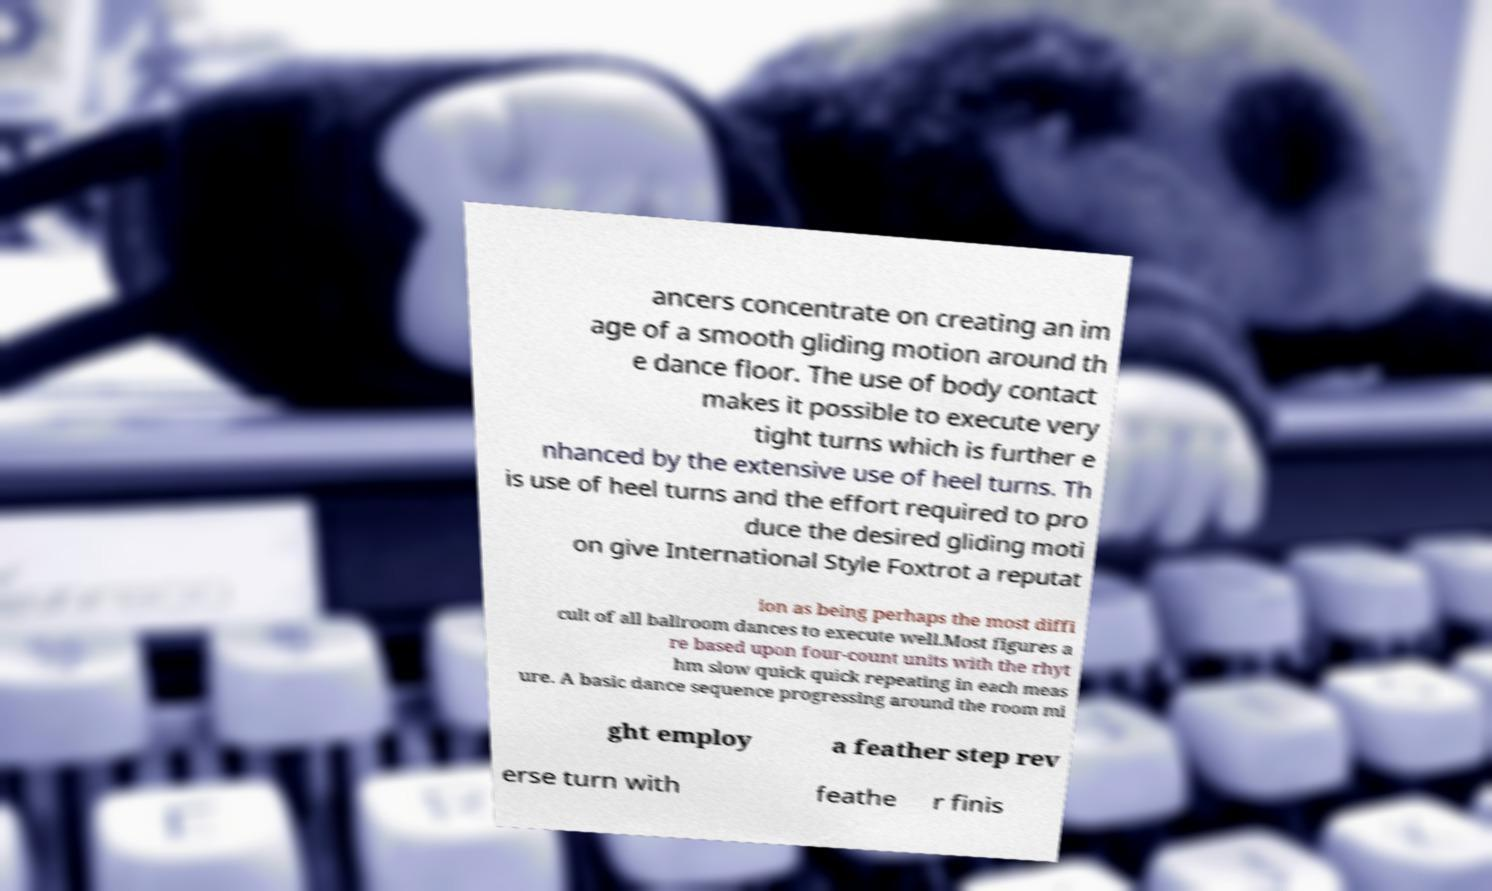There's text embedded in this image that I need extracted. Can you transcribe it verbatim? ancers concentrate on creating an im age of a smooth gliding motion around th e dance floor. The use of body contact makes it possible to execute very tight turns which is further e nhanced by the extensive use of heel turns. Th is use of heel turns and the effort required to pro duce the desired gliding moti on give International Style Foxtrot a reputat ion as being perhaps the most diffi cult of all ballroom dances to execute well.Most figures a re based upon four-count units with the rhyt hm slow quick quick repeating in each meas ure. A basic dance sequence progressing around the room mi ght employ a feather step rev erse turn with feathe r finis 